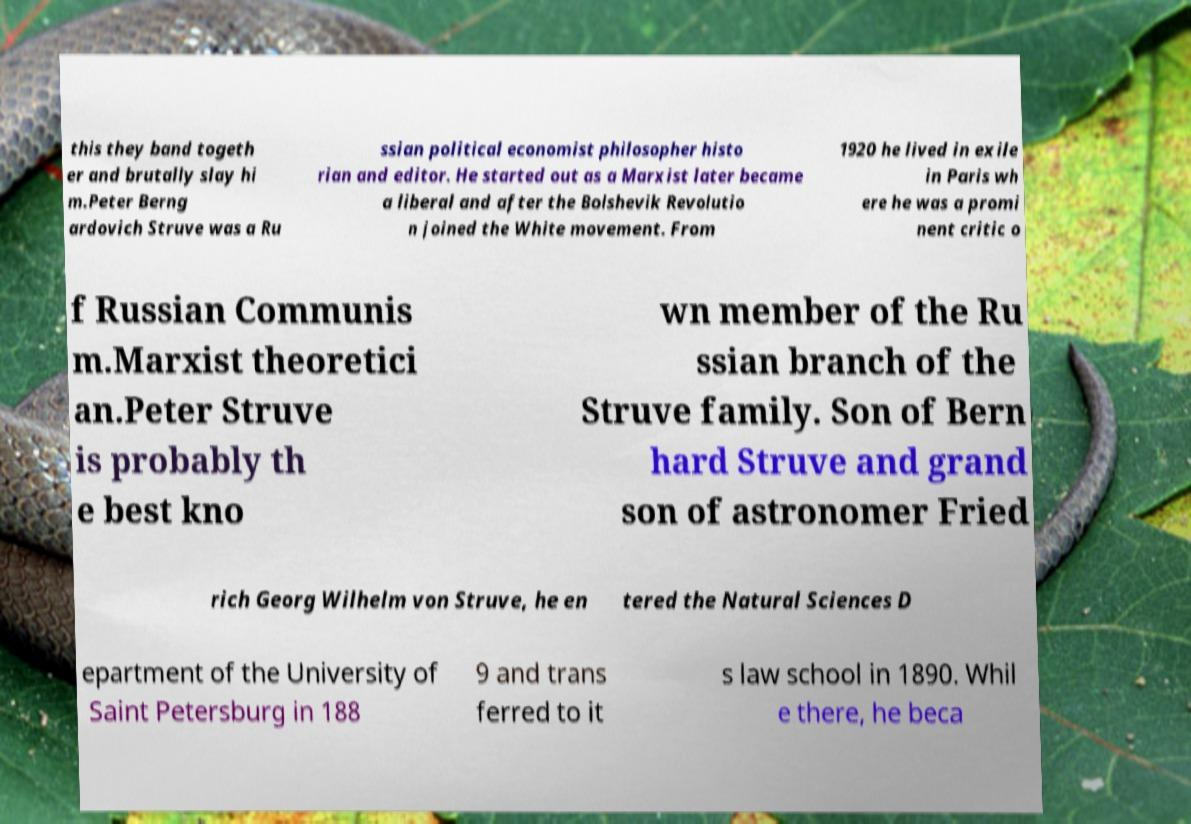What messages or text are displayed in this image? I need them in a readable, typed format. this they band togeth er and brutally slay hi m.Peter Berng ardovich Struve was a Ru ssian political economist philosopher histo rian and editor. He started out as a Marxist later became a liberal and after the Bolshevik Revolutio n joined the White movement. From 1920 he lived in exile in Paris wh ere he was a promi nent critic o f Russian Communis m.Marxist theoretici an.Peter Struve is probably th e best kno wn member of the Ru ssian branch of the Struve family. Son of Bern hard Struve and grand son of astronomer Fried rich Georg Wilhelm von Struve, he en tered the Natural Sciences D epartment of the University of Saint Petersburg in 188 9 and trans ferred to it s law school in 1890. Whil e there, he beca 